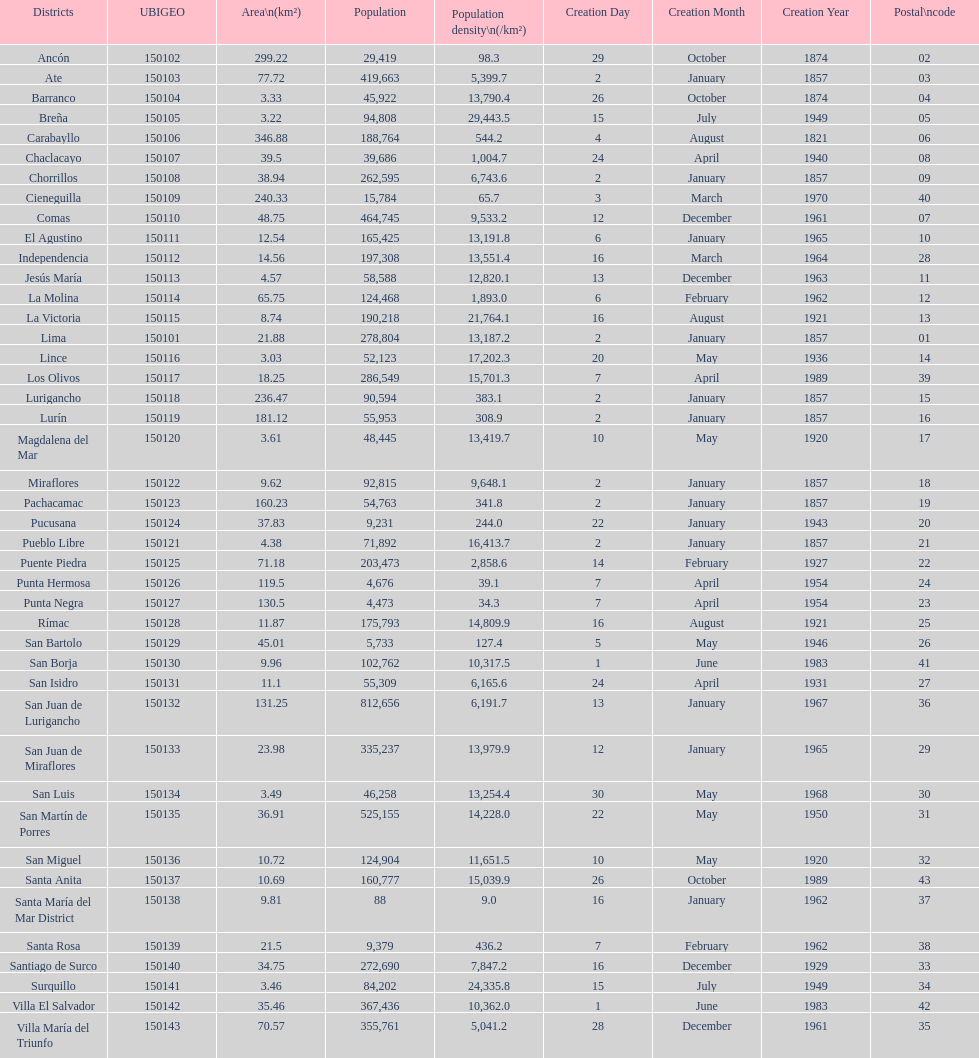What was the last district created? Santa Anita. 